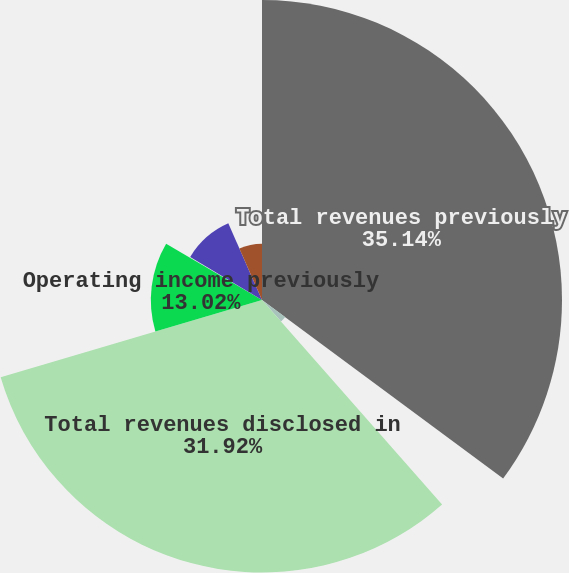Convert chart. <chart><loc_0><loc_0><loc_500><loc_500><pie_chart><fcel>Total revenues previously<fcel>Total revenues subsequently<fcel>Total revenues disclosed in<fcel>Operating income previously<fcel>Operating income subsequently<fcel>Operating income disclosed in<fcel>Income from continuing<nl><fcel>35.14%<fcel>3.37%<fcel>31.92%<fcel>13.02%<fcel>0.15%<fcel>9.81%<fcel>6.59%<nl></chart> 